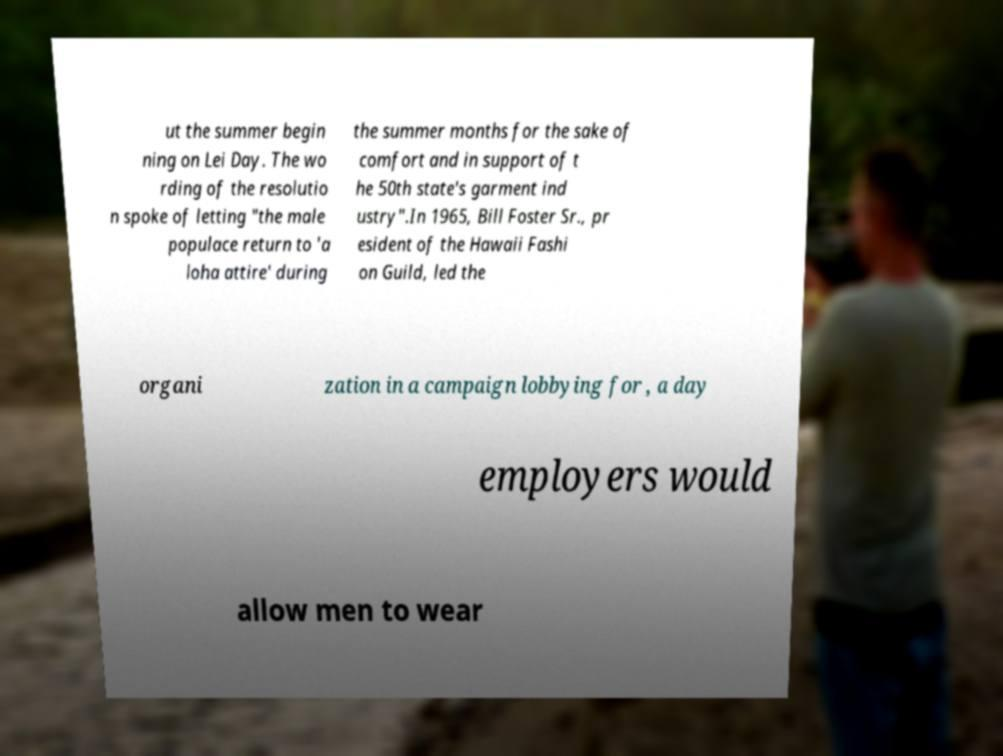For documentation purposes, I need the text within this image transcribed. Could you provide that? ut the summer begin ning on Lei Day. The wo rding of the resolutio n spoke of letting "the male populace return to 'a loha attire' during the summer months for the sake of comfort and in support of t he 50th state's garment ind ustry".In 1965, Bill Foster Sr., pr esident of the Hawaii Fashi on Guild, led the organi zation in a campaign lobbying for , a day employers would allow men to wear 